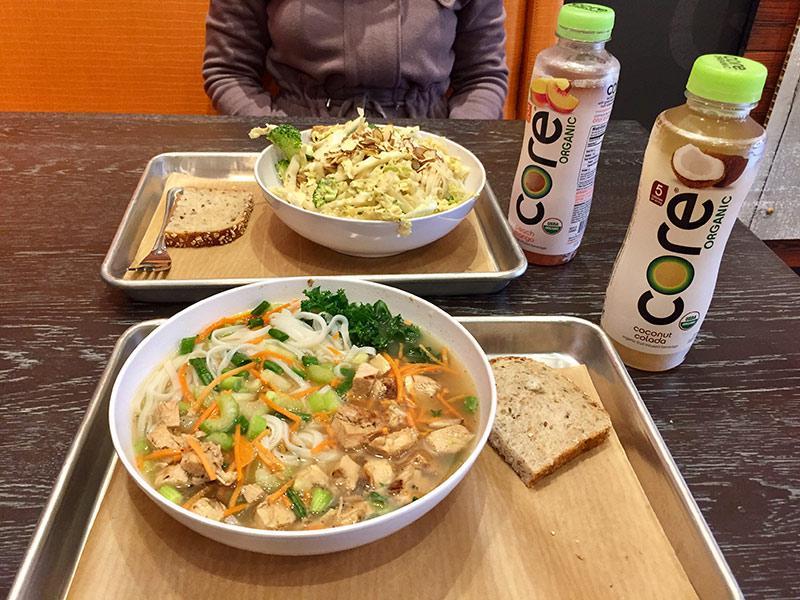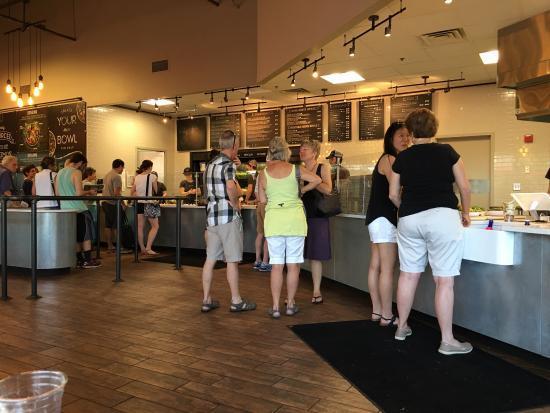The first image is the image on the left, the second image is the image on the right. Evaluate the accuracy of this statement regarding the images: "The left image shows two rows of seats with an aisle of wood-grain floor between them and angled architectural elements above them on the ceiling.". Is it true? Answer yes or no. No. 